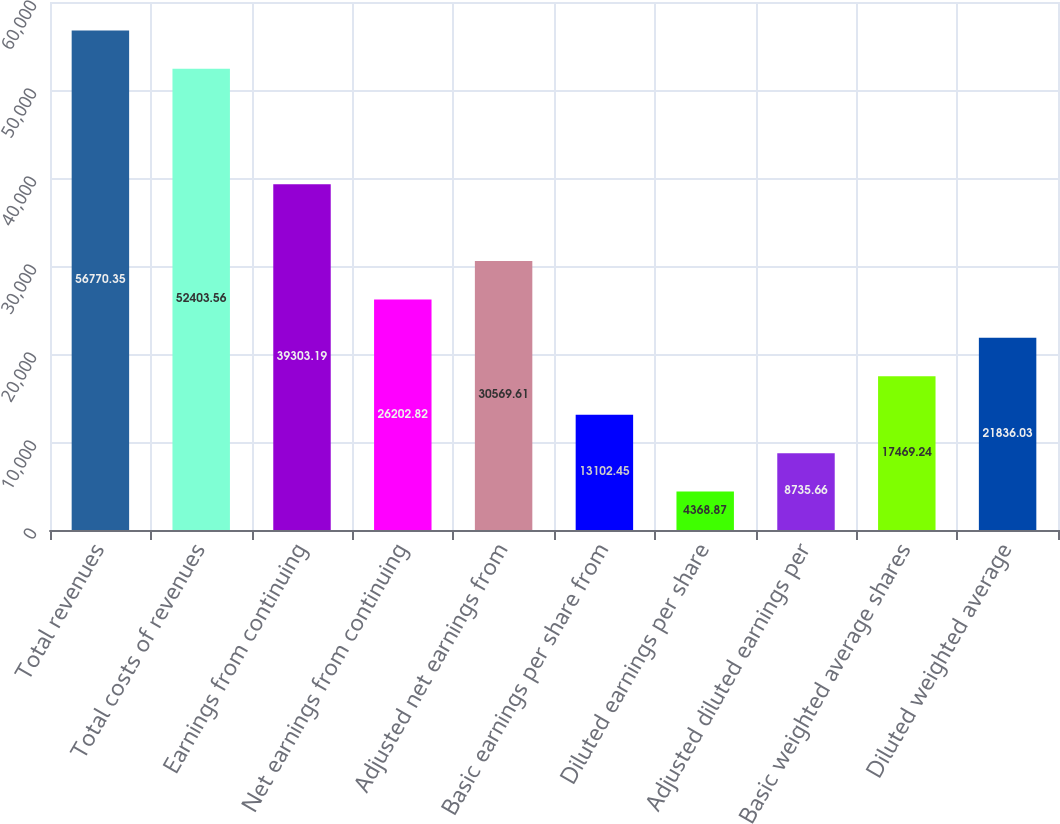<chart> <loc_0><loc_0><loc_500><loc_500><bar_chart><fcel>Total revenues<fcel>Total costs of revenues<fcel>Earnings from continuing<fcel>Net earnings from continuing<fcel>Adjusted net earnings from<fcel>Basic earnings per share from<fcel>Diluted earnings per share<fcel>Adjusted diluted earnings per<fcel>Basic weighted average shares<fcel>Diluted weighted average<nl><fcel>56770.3<fcel>52403.6<fcel>39303.2<fcel>26202.8<fcel>30569.6<fcel>13102.5<fcel>4368.87<fcel>8735.66<fcel>17469.2<fcel>21836<nl></chart> 